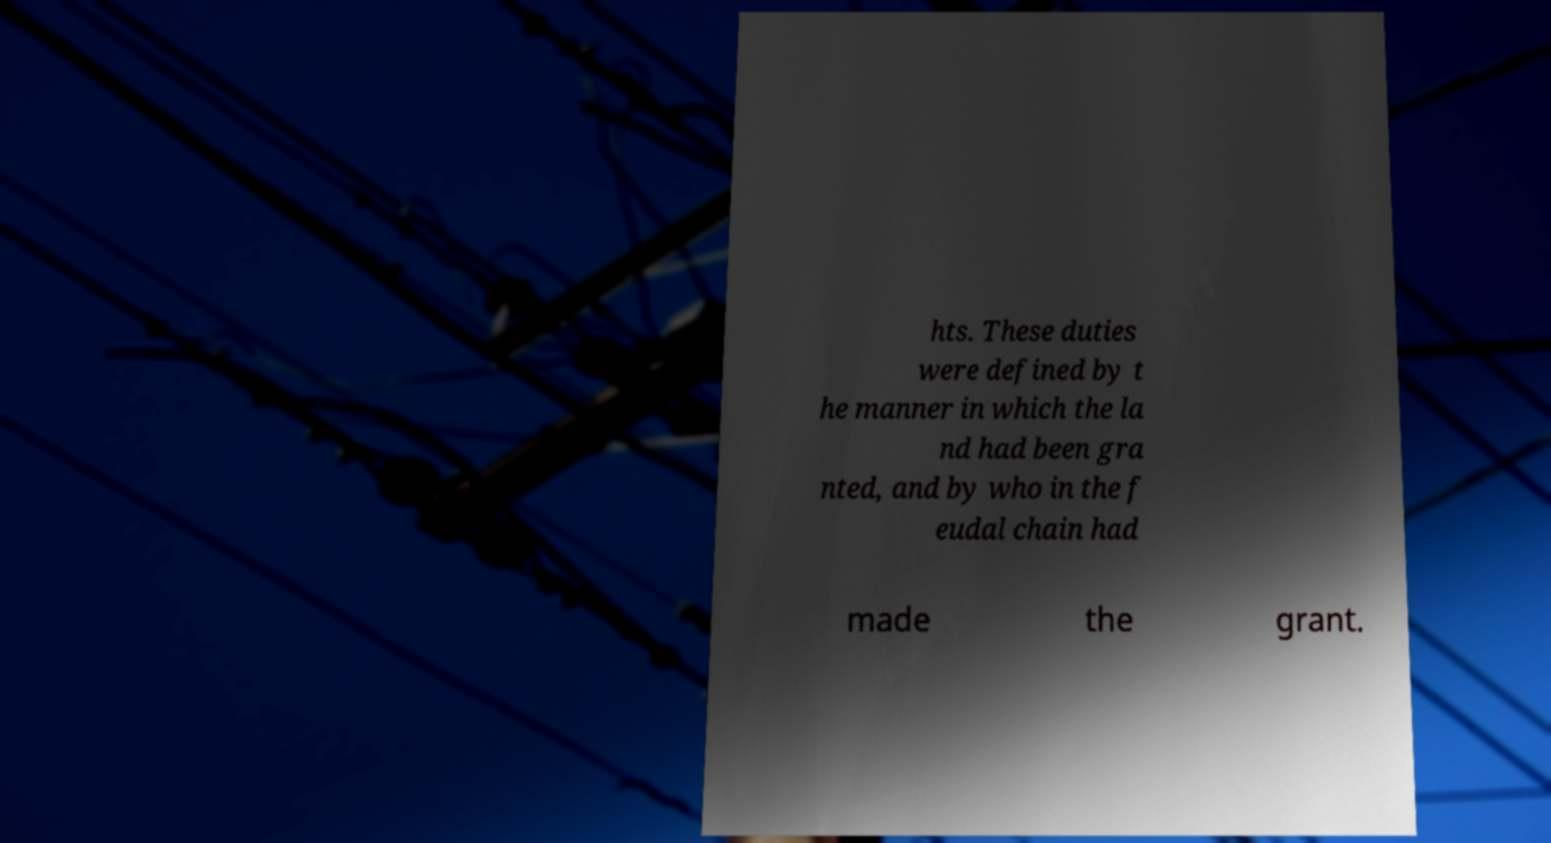Please read and relay the text visible in this image. What does it say? hts. These duties were defined by t he manner in which the la nd had been gra nted, and by who in the f eudal chain had made the grant. 